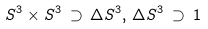Convert formula to latex. <formula><loc_0><loc_0><loc_500><loc_500>S ^ { 3 } \times S ^ { 3 } \, \supset \, \Delta S ^ { 3 } , \, \Delta S ^ { 3 } \, \supset \, 1</formula> 